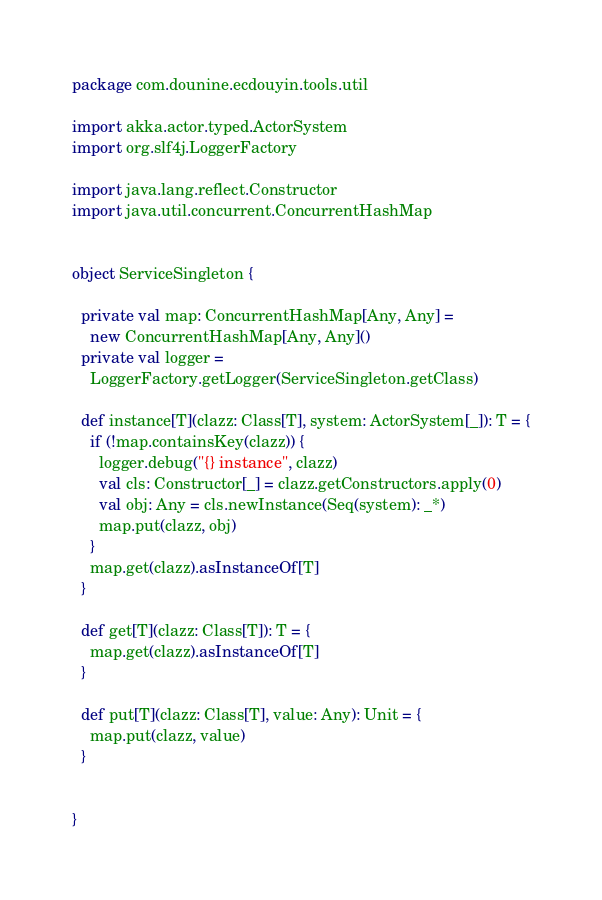Convert code to text. <code><loc_0><loc_0><loc_500><loc_500><_Scala_>package com.dounine.ecdouyin.tools.util

import akka.actor.typed.ActorSystem
import org.slf4j.LoggerFactory

import java.lang.reflect.Constructor
import java.util.concurrent.ConcurrentHashMap


object ServiceSingleton {

  private val map: ConcurrentHashMap[Any, Any] =
    new ConcurrentHashMap[Any, Any]()
  private val logger =
    LoggerFactory.getLogger(ServiceSingleton.getClass)

  def instance[T](clazz: Class[T], system: ActorSystem[_]): T = {
    if (!map.containsKey(clazz)) {
      logger.debug("{} instance", clazz)
      val cls: Constructor[_] = clazz.getConstructors.apply(0)
      val obj: Any = cls.newInstance(Seq(system): _*)
      map.put(clazz, obj)
    }
    map.get(clazz).asInstanceOf[T]
  }

  def get[T](clazz: Class[T]): T = {
    map.get(clazz).asInstanceOf[T]
  }

  def put[T](clazz: Class[T], value: Any): Unit = {
    map.put(clazz, value)
  }


}
</code> 